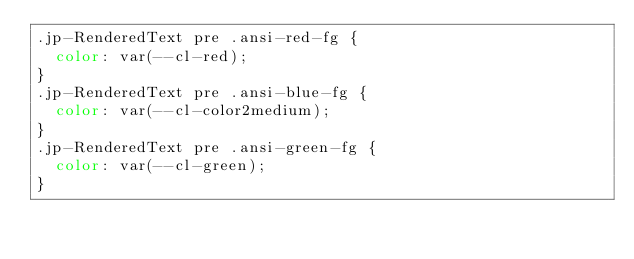Convert code to text. <code><loc_0><loc_0><loc_500><loc_500><_CSS_>.jp-RenderedText pre .ansi-red-fg {
  color: var(--cl-red);
}
.jp-RenderedText pre .ansi-blue-fg {
  color: var(--cl-color2medium);
}
.jp-RenderedText pre .ansi-green-fg {
  color: var(--cl-green);
}
</code> 